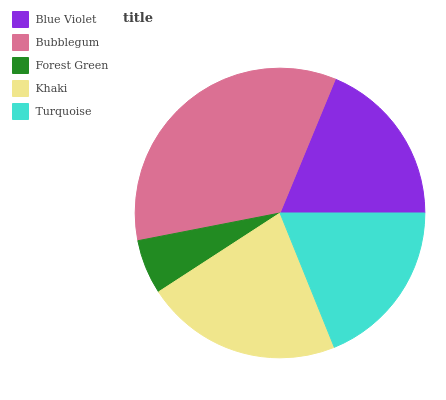Is Forest Green the minimum?
Answer yes or no. Yes. Is Bubblegum the maximum?
Answer yes or no. Yes. Is Bubblegum the minimum?
Answer yes or no. No. Is Forest Green the maximum?
Answer yes or no. No. Is Bubblegum greater than Forest Green?
Answer yes or no. Yes. Is Forest Green less than Bubblegum?
Answer yes or no. Yes. Is Forest Green greater than Bubblegum?
Answer yes or no. No. Is Bubblegum less than Forest Green?
Answer yes or no. No. Is Turquoise the high median?
Answer yes or no. Yes. Is Turquoise the low median?
Answer yes or no. Yes. Is Forest Green the high median?
Answer yes or no. No. Is Khaki the low median?
Answer yes or no. No. 